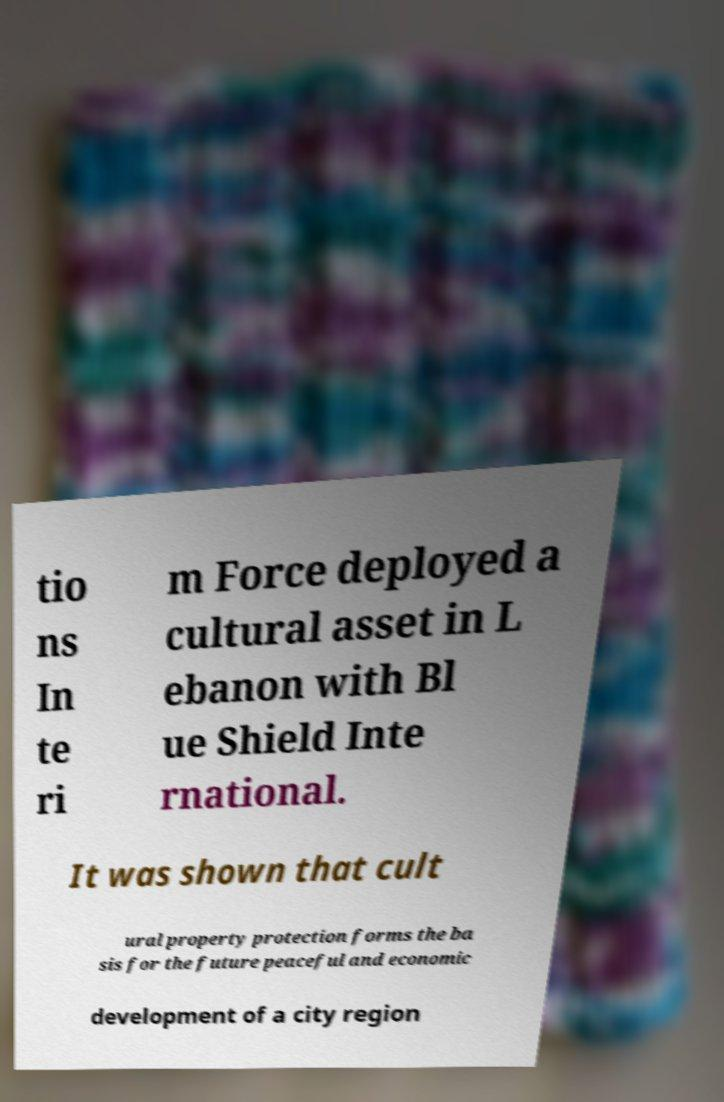What messages or text are displayed in this image? I need them in a readable, typed format. tio ns In te ri m Force deployed a cultural asset in L ebanon with Bl ue Shield Inte rnational. It was shown that cult ural property protection forms the ba sis for the future peaceful and economic development of a city region 